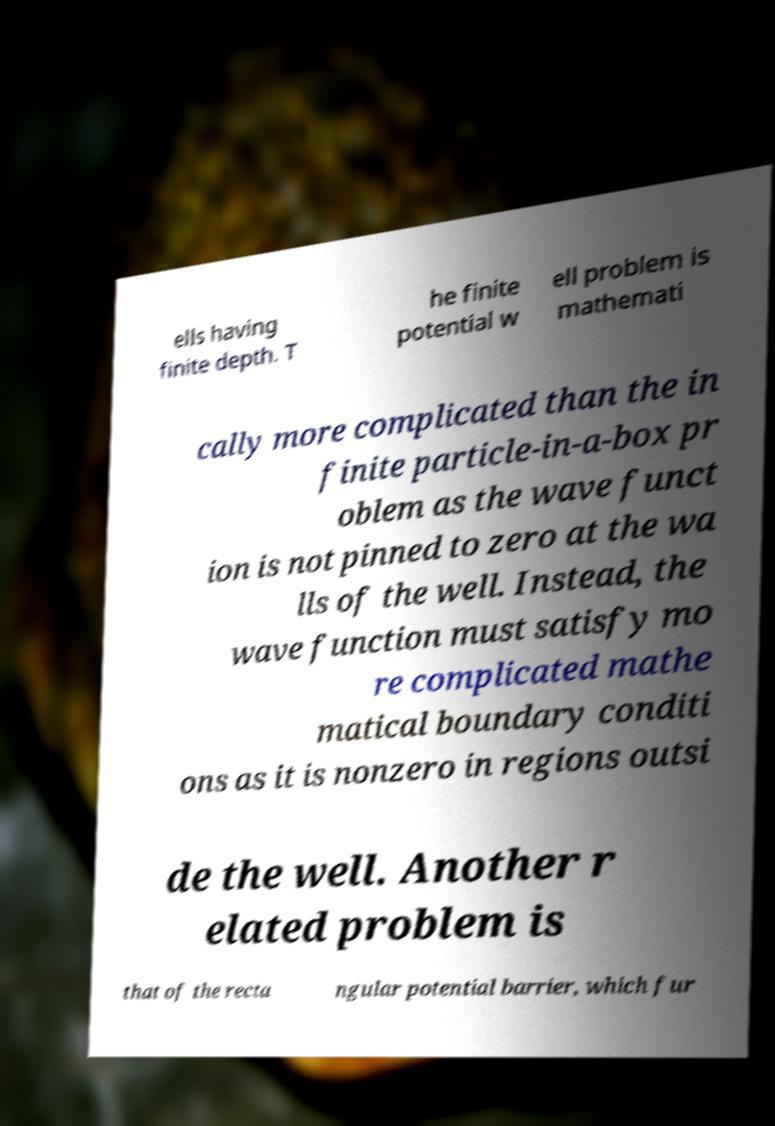Can you accurately transcribe the text from the provided image for me? ells having finite depth. T he finite potential w ell problem is mathemati cally more complicated than the in finite particle-in-a-box pr oblem as the wave funct ion is not pinned to zero at the wa lls of the well. Instead, the wave function must satisfy mo re complicated mathe matical boundary conditi ons as it is nonzero in regions outsi de the well. Another r elated problem is that of the recta ngular potential barrier, which fur 